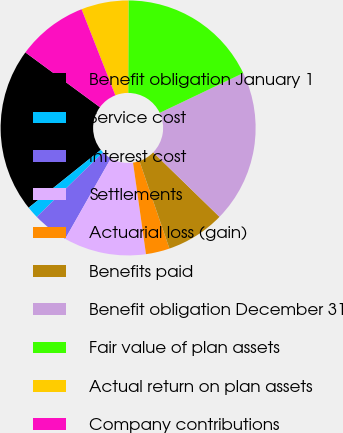Convert chart to OTSL. <chart><loc_0><loc_0><loc_500><loc_500><pie_chart><fcel>Benefit obligation January 1<fcel>Service cost<fcel>Interest cost<fcel>Settlements<fcel>Actuarial loss (gain)<fcel>Benefits paid<fcel>Benefit obligation December 31<fcel>Fair value of plan assets<fcel>Actual return on plan assets<fcel>Company contributions<nl><fcel>20.85%<fcel>1.53%<fcel>4.5%<fcel>10.45%<fcel>3.01%<fcel>7.47%<fcel>19.36%<fcel>17.88%<fcel>5.99%<fcel>8.96%<nl></chart> 